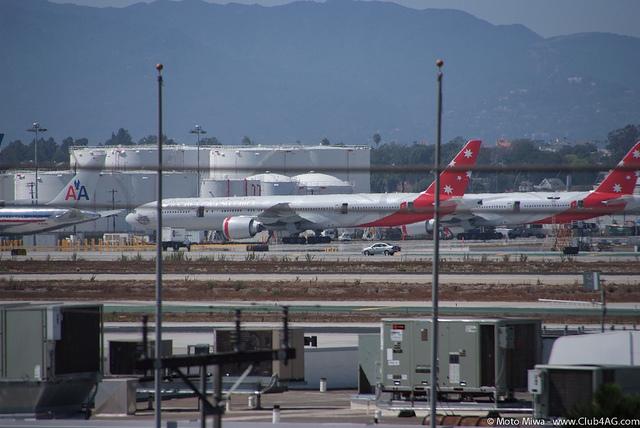Are there mountains in the photo?
Be succinct. Yes. How many planes are there?
Concise answer only. 3. What substance-abuse recovery organization is represented by the same letters on the plane's tail?
Concise answer only. Alcoholics anonymous. 